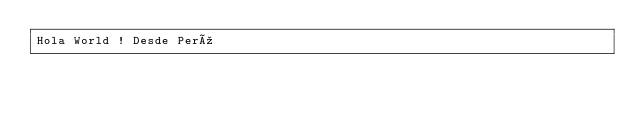<code> <loc_0><loc_0><loc_500><loc_500><_HTML_>Hola World ! Desde Perú
</code> 